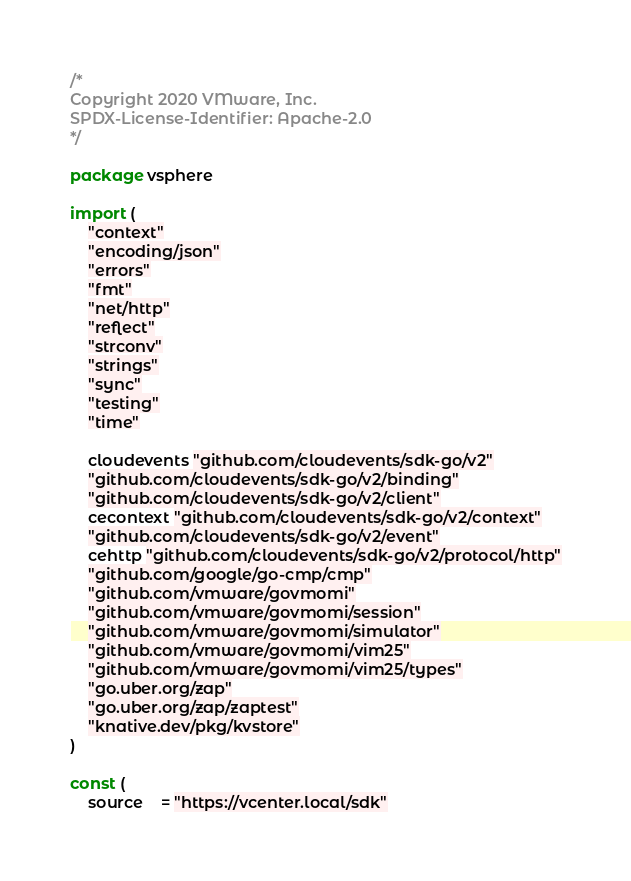<code> <loc_0><loc_0><loc_500><loc_500><_Go_>/*
Copyright 2020 VMware, Inc.
SPDX-License-Identifier: Apache-2.0
*/

package vsphere

import (
	"context"
	"encoding/json"
	"errors"
	"fmt"
	"net/http"
	"reflect"
	"strconv"
	"strings"
	"sync"
	"testing"
	"time"

	cloudevents "github.com/cloudevents/sdk-go/v2"
	"github.com/cloudevents/sdk-go/v2/binding"
	"github.com/cloudevents/sdk-go/v2/client"
	cecontext "github.com/cloudevents/sdk-go/v2/context"
	"github.com/cloudevents/sdk-go/v2/event"
	cehttp "github.com/cloudevents/sdk-go/v2/protocol/http"
	"github.com/google/go-cmp/cmp"
	"github.com/vmware/govmomi"
	"github.com/vmware/govmomi/session"
	"github.com/vmware/govmomi/simulator"
	"github.com/vmware/govmomi/vim25"
	"github.com/vmware/govmomi/vim25/types"
	"go.uber.org/zap"
	"go.uber.org/zap/zaptest"
	"knative.dev/pkg/kvstore"
)

const (
	source    = "https://vcenter.local/sdk"</code> 